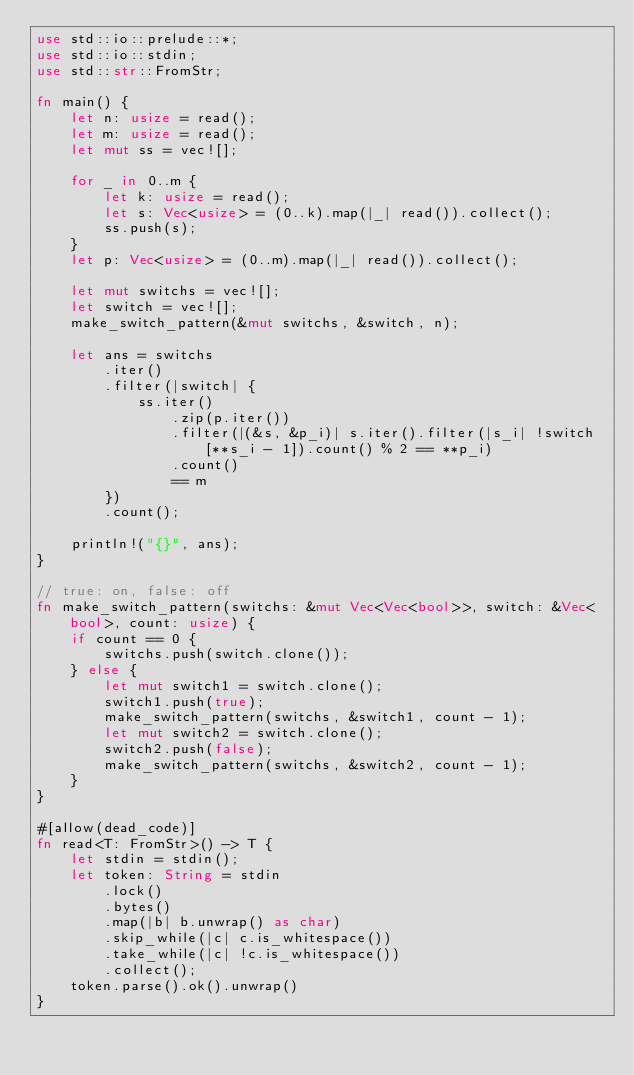<code> <loc_0><loc_0><loc_500><loc_500><_Rust_>use std::io::prelude::*;
use std::io::stdin;
use std::str::FromStr;

fn main() {
    let n: usize = read();
    let m: usize = read();
    let mut ss = vec![];

    for _ in 0..m {
        let k: usize = read();
        let s: Vec<usize> = (0..k).map(|_| read()).collect();
        ss.push(s);
    }
    let p: Vec<usize> = (0..m).map(|_| read()).collect();

    let mut switchs = vec![];
    let switch = vec![];
    make_switch_pattern(&mut switchs, &switch, n);

    let ans = switchs
        .iter()
        .filter(|switch| {
            ss.iter()
                .zip(p.iter())
                .filter(|(&s, &p_i)| s.iter().filter(|s_i| !switch[**s_i - 1]).count() % 2 == **p_i)
                .count()
                == m
        })
        .count();

    println!("{}", ans);
}

// true: on, false: off
fn make_switch_pattern(switchs: &mut Vec<Vec<bool>>, switch: &Vec<bool>, count: usize) {
    if count == 0 {
        switchs.push(switch.clone());
    } else {
        let mut switch1 = switch.clone();
        switch1.push(true);
        make_switch_pattern(switchs, &switch1, count - 1);
        let mut switch2 = switch.clone();
        switch2.push(false);
        make_switch_pattern(switchs, &switch2, count - 1);
    }
}

#[allow(dead_code)]
fn read<T: FromStr>() -> T {
    let stdin = stdin();
    let token: String = stdin
        .lock()
        .bytes()
        .map(|b| b.unwrap() as char)
        .skip_while(|c| c.is_whitespace())
        .take_while(|c| !c.is_whitespace())
        .collect();
    token.parse().ok().unwrap()
}
</code> 